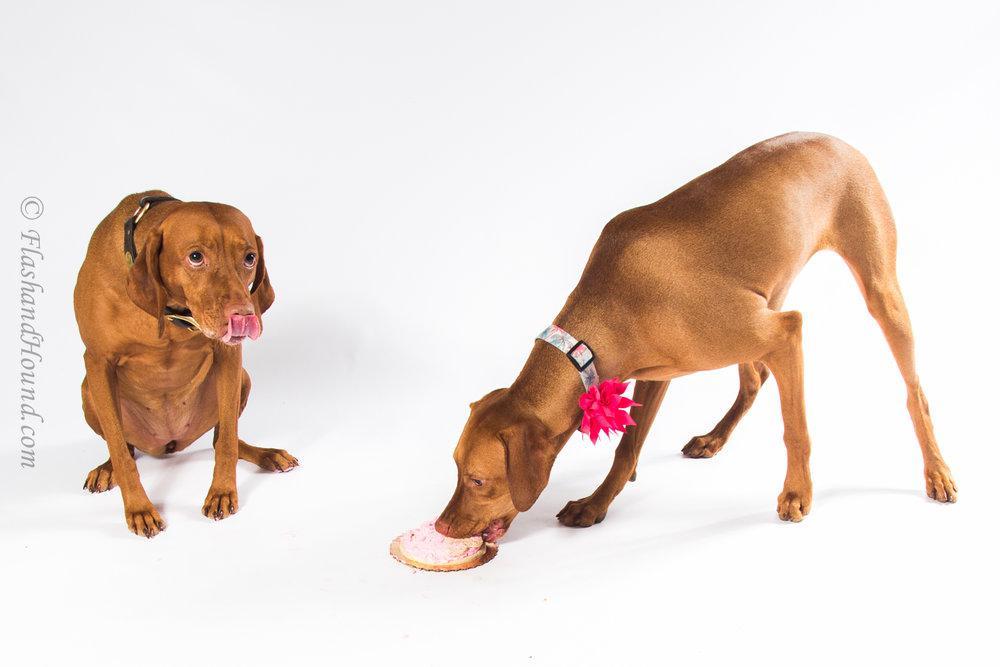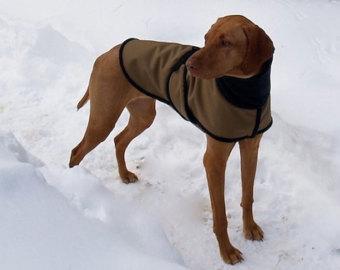The first image is the image on the left, the second image is the image on the right. Assess this claim about the two images: "The left and right image contains the same number of dogs.". Correct or not? Answer yes or no. No. The first image is the image on the left, the second image is the image on the right. Given the left and right images, does the statement "The left image shows two leftward-facing red-orange dogs, and at least one of them is sitting upright." hold true? Answer yes or no. No. 